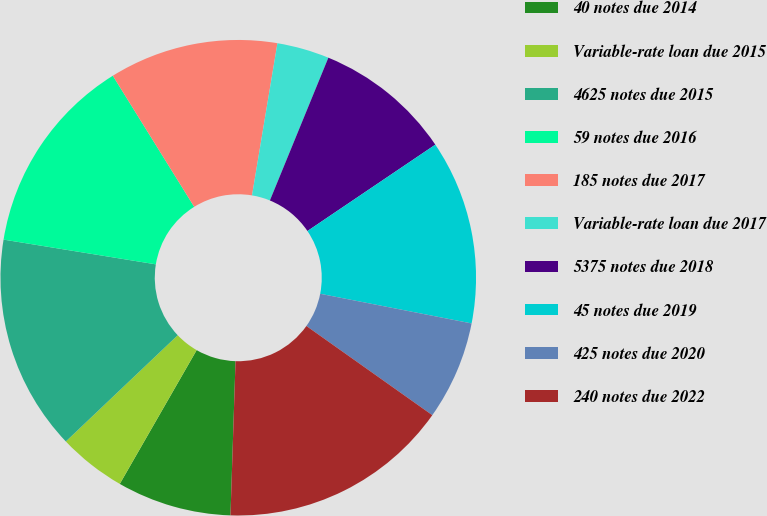Convert chart to OTSL. <chart><loc_0><loc_0><loc_500><loc_500><pie_chart><fcel>40 notes due 2014<fcel>Variable-rate loan due 2015<fcel>4625 notes due 2015<fcel>59 notes due 2016<fcel>185 notes due 2017<fcel>Variable-rate loan due 2017<fcel>5375 notes due 2018<fcel>45 notes due 2019<fcel>425 notes due 2020<fcel>240 notes due 2022<nl><fcel>7.78%<fcel>4.61%<fcel>14.65%<fcel>13.59%<fcel>11.48%<fcel>3.55%<fcel>9.36%<fcel>12.53%<fcel>6.73%<fcel>15.71%<nl></chart> 